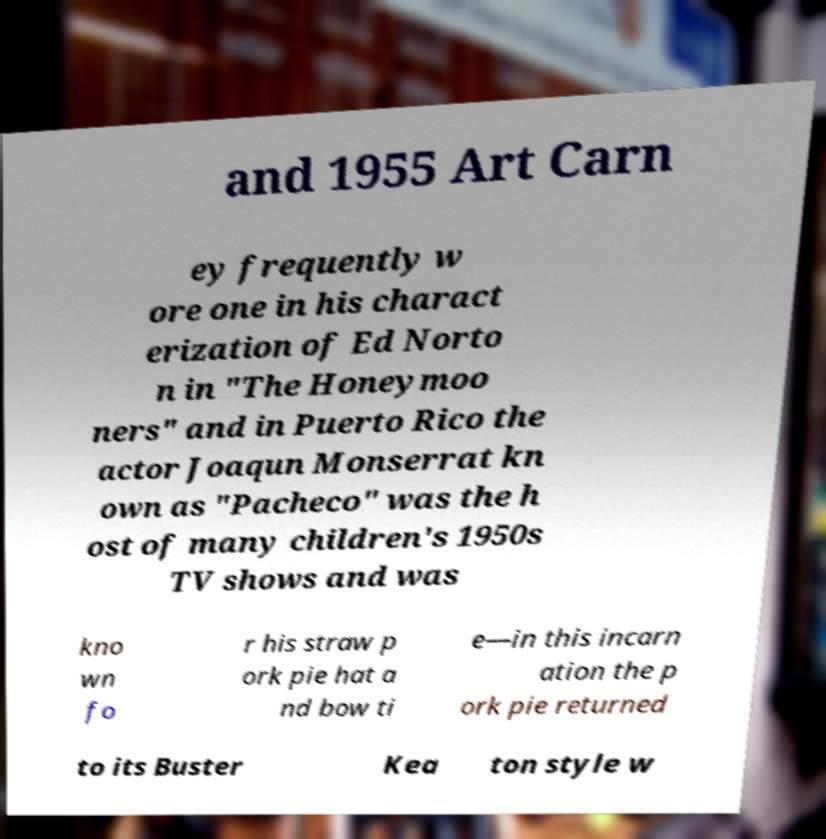What messages or text are displayed in this image? I need them in a readable, typed format. and 1955 Art Carn ey frequently w ore one in his charact erization of Ed Norto n in "The Honeymoo ners" and in Puerto Rico the actor Joaqun Monserrat kn own as "Pacheco" was the h ost of many children's 1950s TV shows and was kno wn fo r his straw p ork pie hat a nd bow ti e—in this incarn ation the p ork pie returned to its Buster Kea ton style w 